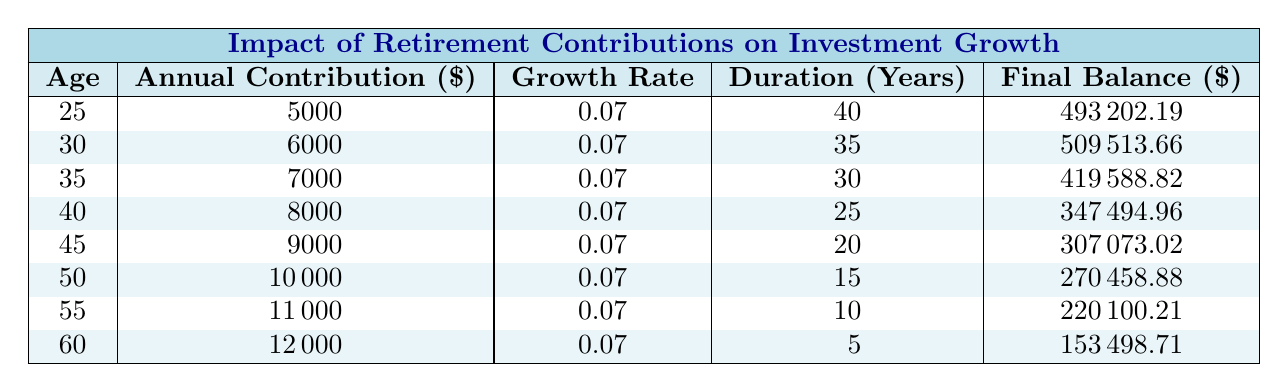What is the final balance at age 25? From the table, locate the row for age 25, where the final balance is stated as 493202.19.
Answer: 493202.19 What is the highest annual contribution listed in the table? By reviewing the "Annual Contribution" column, the maximum value is 12000, corresponding to age 60.
Answer: 12000 What is the final balance for someone who contributes 8000 annually? The table indicates that the final balance for an annual contribution of 8000, at age 40, is 347494.96.
Answer: 347494.96 What is the average final balance for ages 25 to 45? The final balances for ages 25, 30, 35, 40, and 45 are 493202.19, 509513.66, 419588.82, 347494.96, and 307073.02 respectively. Summing these amounts: 493202.19 + 509513.66 + 419588.82 + 347494.96 + 307073.02 = 2075872.65. There are 5 values, so the average is 2075872.65 / 5 = 415174.53.
Answer: 415174.53 Is the final balance higher for those who start contributing later? By comparing final balances, we see that those starting at age 25 (493202.19) have a higher balance than those starting at age 55 (220100.21). Therefore, starting later yields lower final balances.
Answer: No 